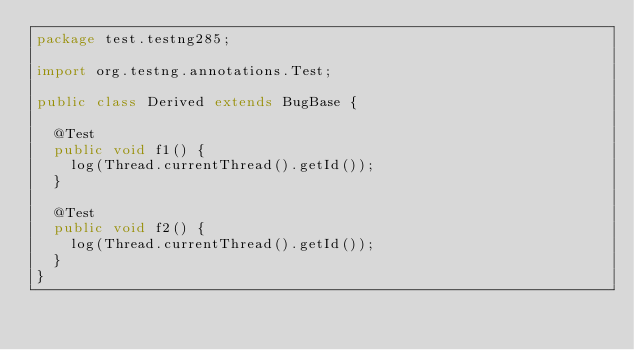Convert code to text. <code><loc_0><loc_0><loc_500><loc_500><_Java_>package test.testng285;

import org.testng.annotations.Test;

public class Derived extends BugBase {
  
  @Test
  public void f1() {
    log(Thread.currentThread().getId());
  }

  @Test
  public void f2() {
    log(Thread.currentThread().getId());
  }
}
</code> 